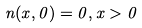Convert formula to latex. <formula><loc_0><loc_0><loc_500><loc_500>n ( x , 0 ) = 0 , x > 0</formula> 